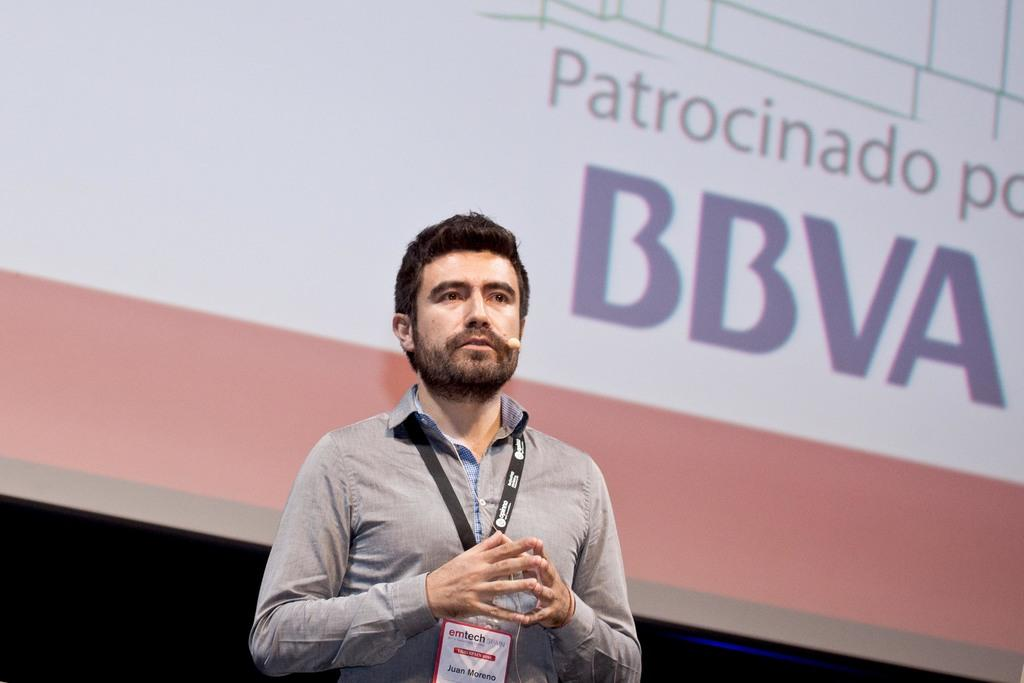<image>
Render a clear and concise summary of the photo. a man standing in front of a projection screen that says 'bbva' on it 